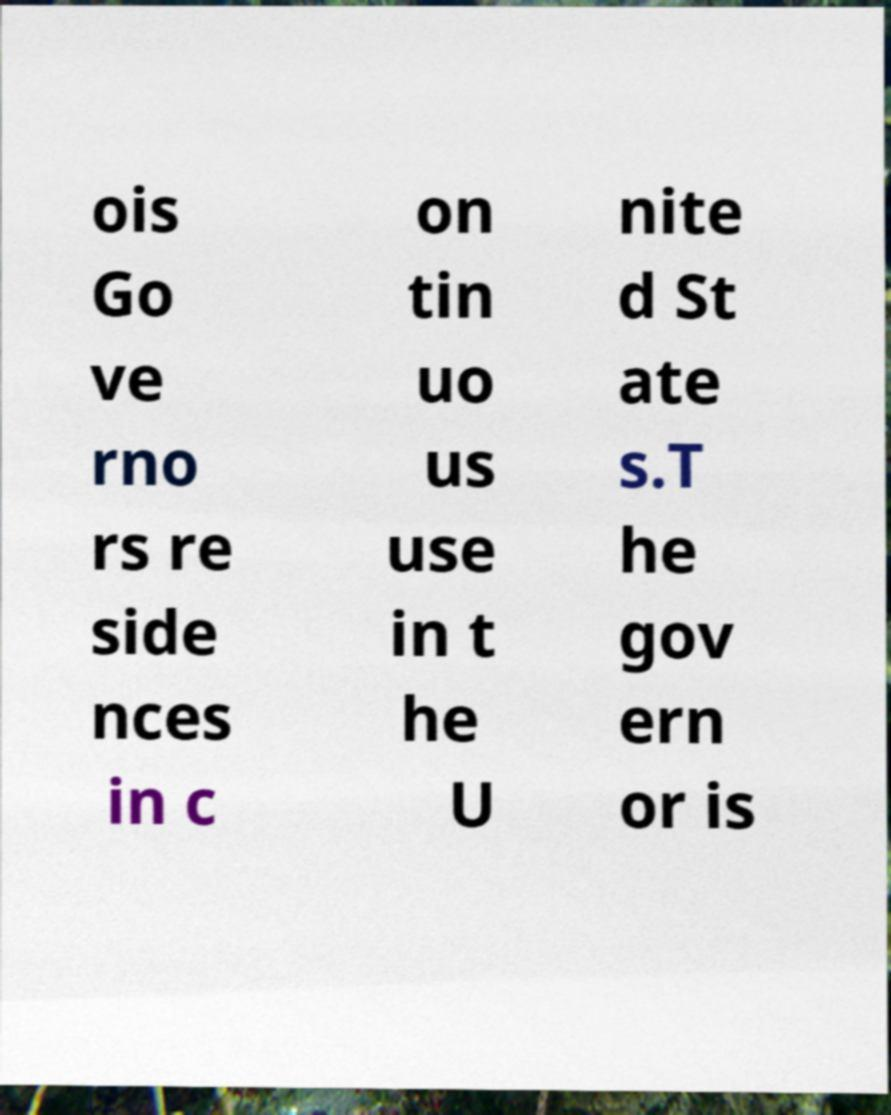Please read and relay the text visible in this image. What does it say? ois Go ve rno rs re side nces in c on tin uo us use in t he U nite d St ate s.T he gov ern or is 